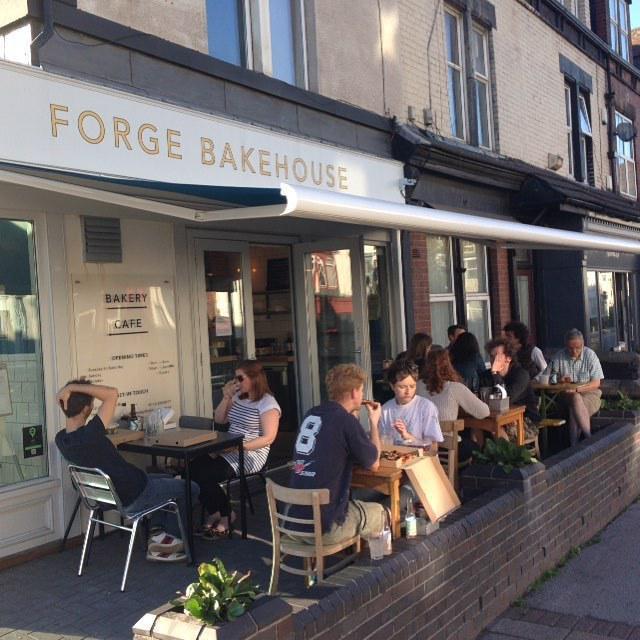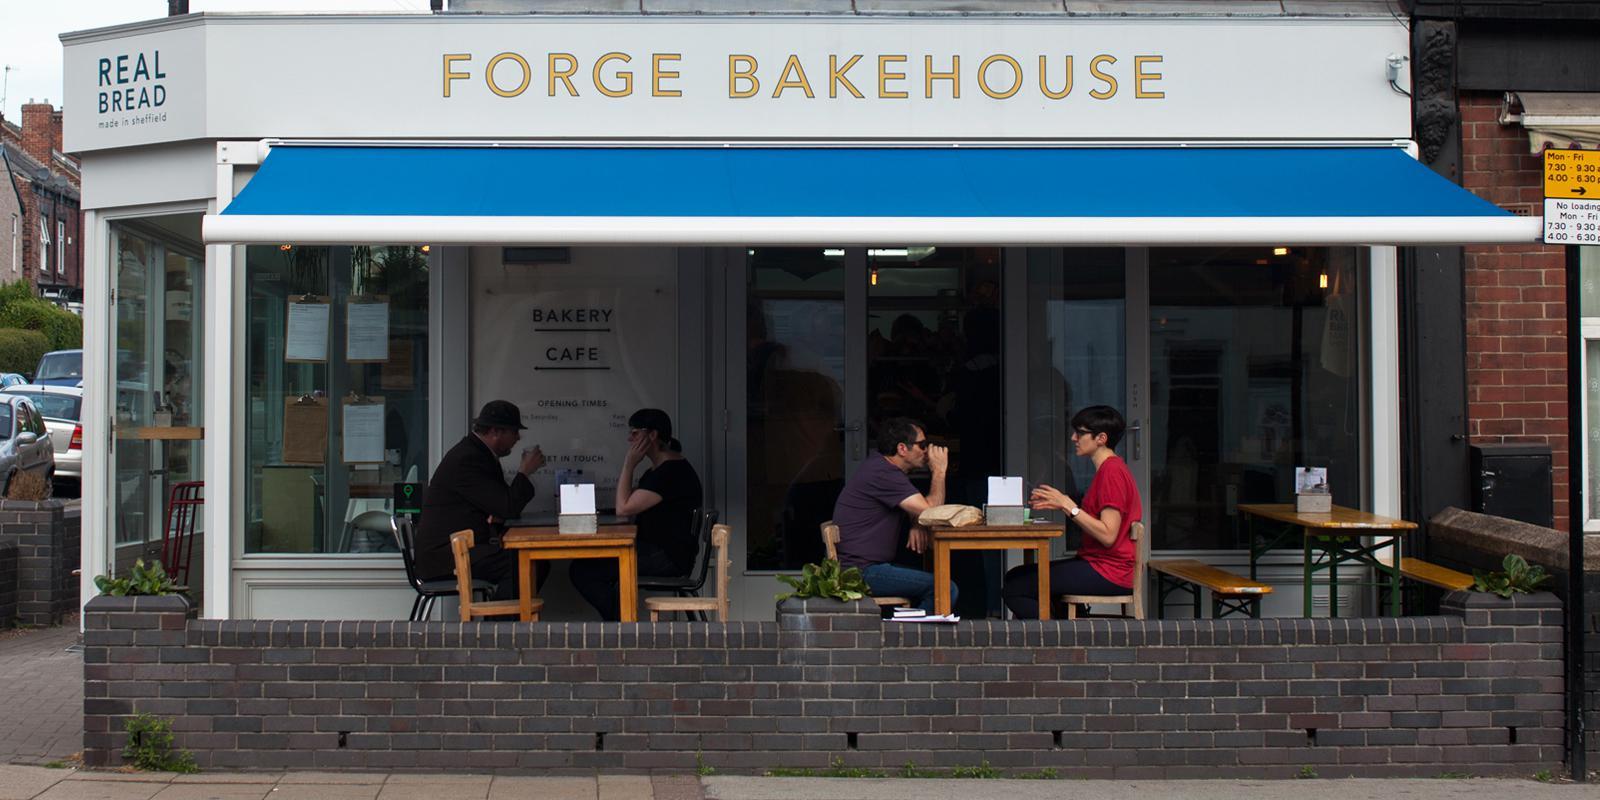The first image is the image on the left, the second image is the image on the right. Considering the images on both sides, is "An outside view of the Forge Bakehouse." valid? Answer yes or no. Yes. The first image is the image on the left, the second image is the image on the right. Assess this claim about the two images: "Both images are of the outside of the store.". Correct or not? Answer yes or no. Yes. 